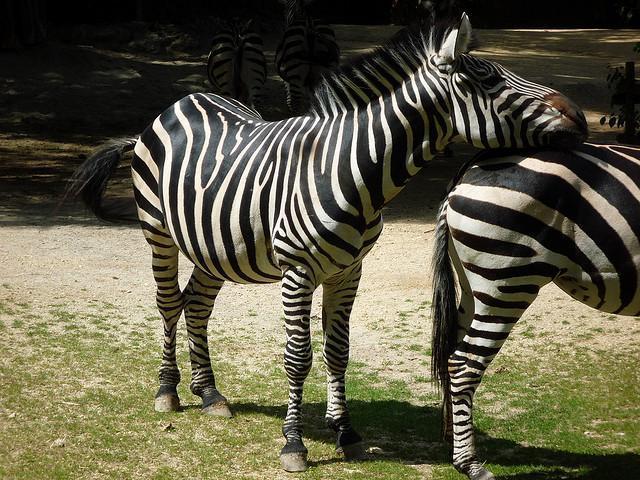How many zebras are in the picture?
Give a very brief answer. 2. How many zebras can you see?
Give a very brief answer. 4. 